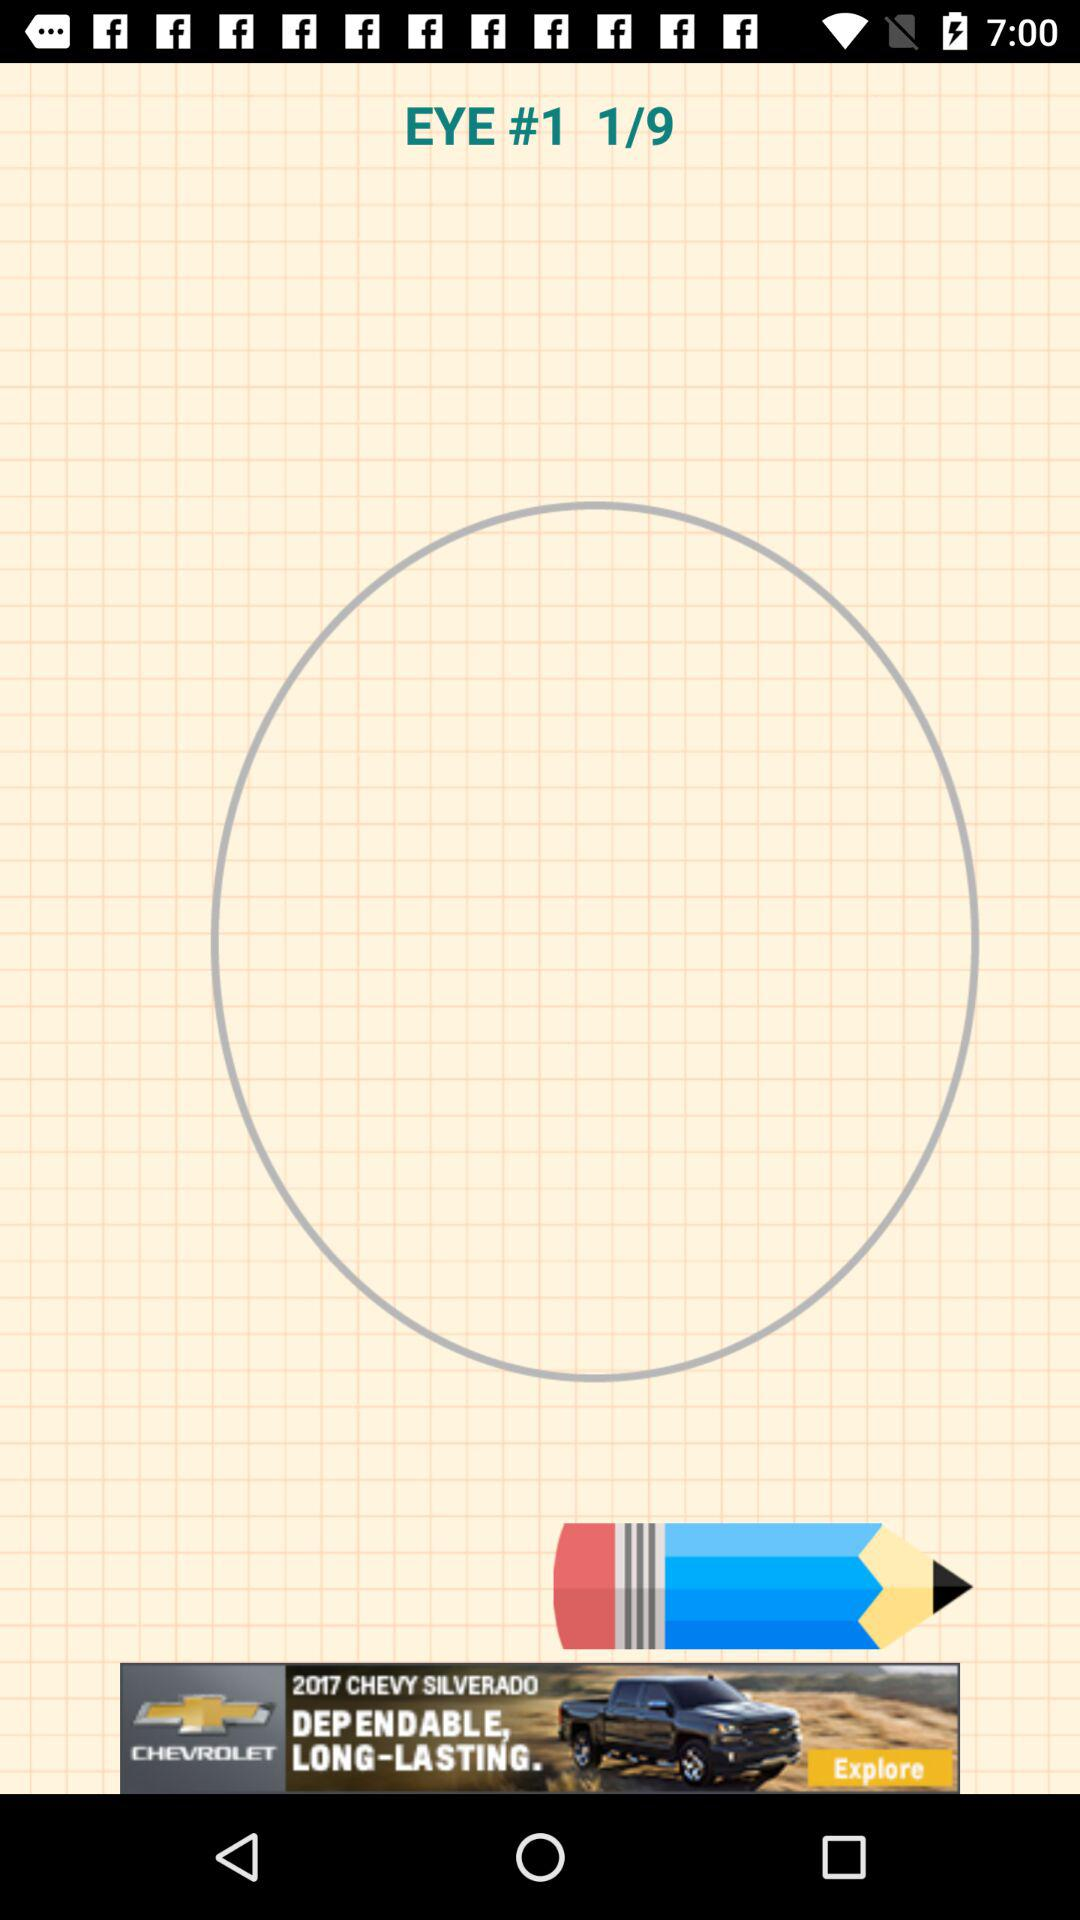What is the total number of slides? The total number of slides is 9. 